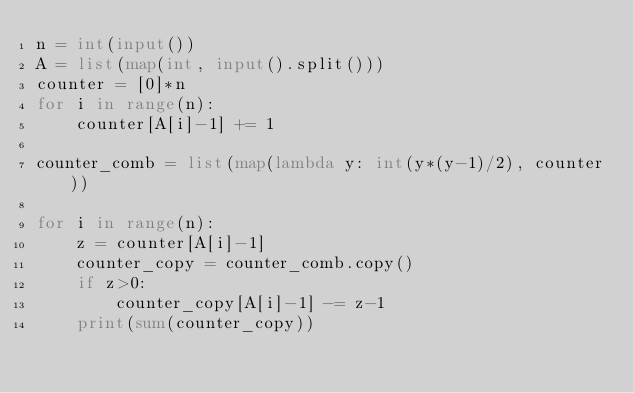Convert code to text. <code><loc_0><loc_0><loc_500><loc_500><_Python_>n = int(input())
A = list(map(int, input().split()))
counter = [0]*n
for i in range(n):
    counter[A[i]-1] += 1

counter_comb = list(map(lambda y: int(y*(y-1)/2), counter))

for i in range(n):
    z = counter[A[i]-1]
    counter_copy = counter_comb.copy()
    if z>0:
        counter_copy[A[i]-1] -= z-1
    print(sum(counter_copy))
    </code> 